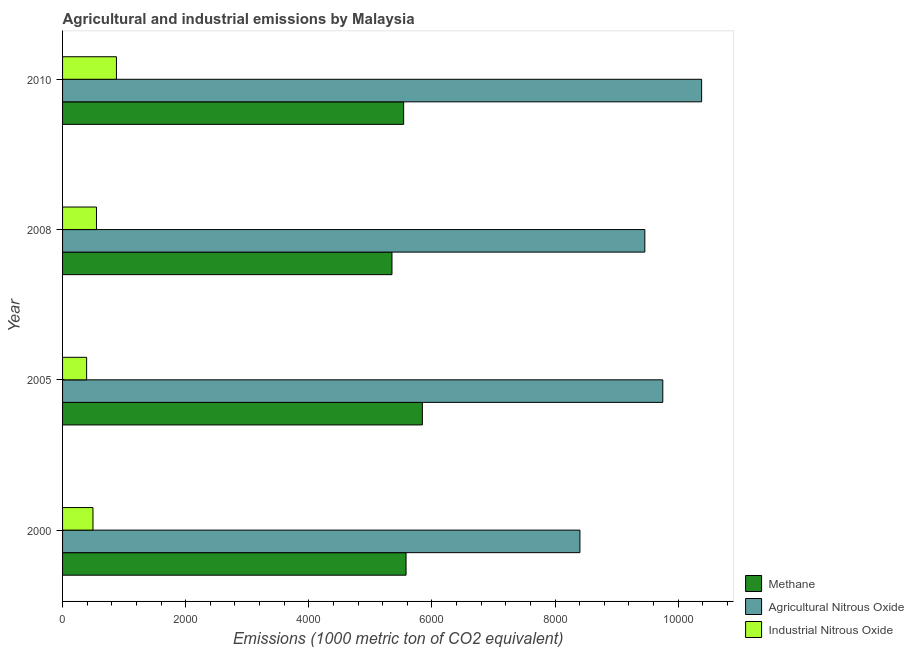How many groups of bars are there?
Provide a succinct answer. 4. Are the number of bars per tick equal to the number of legend labels?
Give a very brief answer. Yes. What is the label of the 3rd group of bars from the top?
Keep it short and to the point. 2005. In how many cases, is the number of bars for a given year not equal to the number of legend labels?
Provide a succinct answer. 0. What is the amount of industrial nitrous oxide emissions in 2010?
Ensure brevity in your answer.  874.9. Across all years, what is the maximum amount of methane emissions?
Provide a succinct answer. 5844. Across all years, what is the minimum amount of methane emissions?
Provide a short and direct response. 5350.3. In which year was the amount of agricultural nitrous oxide emissions maximum?
Make the answer very short. 2010. In which year was the amount of industrial nitrous oxide emissions minimum?
Offer a very short reply. 2005. What is the total amount of agricultural nitrous oxide emissions in the graph?
Give a very brief answer. 3.80e+04. What is the difference between the amount of methane emissions in 2000 and that in 2005?
Keep it short and to the point. -264.8. What is the difference between the amount of agricultural nitrous oxide emissions in 2000 and the amount of industrial nitrous oxide emissions in 2005?
Your answer should be compact. 8012.3. What is the average amount of methane emissions per year?
Give a very brief answer. 5578.45. In the year 2000, what is the difference between the amount of industrial nitrous oxide emissions and amount of methane emissions?
Provide a short and direct response. -5085.4. What is the ratio of the amount of methane emissions in 2000 to that in 2010?
Make the answer very short. 1.01. Is the amount of methane emissions in 2005 less than that in 2008?
Your answer should be very brief. No. What is the difference between the highest and the second highest amount of agricultural nitrous oxide emissions?
Give a very brief answer. 630.9. What is the difference between the highest and the lowest amount of agricultural nitrous oxide emissions?
Give a very brief answer. 1977. In how many years, is the amount of agricultural nitrous oxide emissions greater than the average amount of agricultural nitrous oxide emissions taken over all years?
Your answer should be very brief. 2. Is the sum of the amount of industrial nitrous oxide emissions in 2005 and 2010 greater than the maximum amount of methane emissions across all years?
Give a very brief answer. No. What does the 2nd bar from the top in 2010 represents?
Provide a succinct answer. Agricultural Nitrous Oxide. What does the 2nd bar from the bottom in 2010 represents?
Offer a very short reply. Agricultural Nitrous Oxide. Is it the case that in every year, the sum of the amount of methane emissions and amount of agricultural nitrous oxide emissions is greater than the amount of industrial nitrous oxide emissions?
Offer a very short reply. Yes. Are all the bars in the graph horizontal?
Provide a succinct answer. Yes. How many years are there in the graph?
Provide a short and direct response. 4. What is the difference between two consecutive major ticks on the X-axis?
Provide a succinct answer. 2000. Are the values on the major ticks of X-axis written in scientific E-notation?
Offer a terse response. No. Where does the legend appear in the graph?
Your answer should be very brief. Bottom right. What is the title of the graph?
Offer a very short reply. Agricultural and industrial emissions by Malaysia. What is the label or title of the X-axis?
Your answer should be compact. Emissions (1000 metric ton of CO2 equivalent). What is the Emissions (1000 metric ton of CO2 equivalent) of Methane in 2000?
Provide a short and direct response. 5579.2. What is the Emissions (1000 metric ton of CO2 equivalent) of Agricultural Nitrous Oxide in 2000?
Your answer should be compact. 8403.2. What is the Emissions (1000 metric ton of CO2 equivalent) in Industrial Nitrous Oxide in 2000?
Keep it short and to the point. 493.8. What is the Emissions (1000 metric ton of CO2 equivalent) in Methane in 2005?
Provide a succinct answer. 5844. What is the Emissions (1000 metric ton of CO2 equivalent) in Agricultural Nitrous Oxide in 2005?
Your answer should be very brief. 9749.3. What is the Emissions (1000 metric ton of CO2 equivalent) of Industrial Nitrous Oxide in 2005?
Your answer should be very brief. 390.9. What is the Emissions (1000 metric ton of CO2 equivalent) in Methane in 2008?
Ensure brevity in your answer.  5350.3. What is the Emissions (1000 metric ton of CO2 equivalent) in Agricultural Nitrous Oxide in 2008?
Provide a succinct answer. 9457.6. What is the Emissions (1000 metric ton of CO2 equivalent) of Industrial Nitrous Oxide in 2008?
Ensure brevity in your answer.  551. What is the Emissions (1000 metric ton of CO2 equivalent) of Methane in 2010?
Keep it short and to the point. 5540.3. What is the Emissions (1000 metric ton of CO2 equivalent) in Agricultural Nitrous Oxide in 2010?
Ensure brevity in your answer.  1.04e+04. What is the Emissions (1000 metric ton of CO2 equivalent) of Industrial Nitrous Oxide in 2010?
Your answer should be very brief. 874.9. Across all years, what is the maximum Emissions (1000 metric ton of CO2 equivalent) in Methane?
Give a very brief answer. 5844. Across all years, what is the maximum Emissions (1000 metric ton of CO2 equivalent) in Agricultural Nitrous Oxide?
Make the answer very short. 1.04e+04. Across all years, what is the maximum Emissions (1000 metric ton of CO2 equivalent) of Industrial Nitrous Oxide?
Offer a terse response. 874.9. Across all years, what is the minimum Emissions (1000 metric ton of CO2 equivalent) of Methane?
Provide a short and direct response. 5350.3. Across all years, what is the minimum Emissions (1000 metric ton of CO2 equivalent) in Agricultural Nitrous Oxide?
Provide a short and direct response. 8403.2. Across all years, what is the minimum Emissions (1000 metric ton of CO2 equivalent) in Industrial Nitrous Oxide?
Ensure brevity in your answer.  390.9. What is the total Emissions (1000 metric ton of CO2 equivalent) in Methane in the graph?
Ensure brevity in your answer.  2.23e+04. What is the total Emissions (1000 metric ton of CO2 equivalent) in Agricultural Nitrous Oxide in the graph?
Make the answer very short. 3.80e+04. What is the total Emissions (1000 metric ton of CO2 equivalent) of Industrial Nitrous Oxide in the graph?
Offer a terse response. 2310.6. What is the difference between the Emissions (1000 metric ton of CO2 equivalent) of Methane in 2000 and that in 2005?
Offer a very short reply. -264.8. What is the difference between the Emissions (1000 metric ton of CO2 equivalent) of Agricultural Nitrous Oxide in 2000 and that in 2005?
Offer a very short reply. -1346.1. What is the difference between the Emissions (1000 metric ton of CO2 equivalent) of Industrial Nitrous Oxide in 2000 and that in 2005?
Offer a terse response. 102.9. What is the difference between the Emissions (1000 metric ton of CO2 equivalent) of Methane in 2000 and that in 2008?
Provide a short and direct response. 228.9. What is the difference between the Emissions (1000 metric ton of CO2 equivalent) in Agricultural Nitrous Oxide in 2000 and that in 2008?
Your answer should be very brief. -1054.4. What is the difference between the Emissions (1000 metric ton of CO2 equivalent) of Industrial Nitrous Oxide in 2000 and that in 2008?
Give a very brief answer. -57.2. What is the difference between the Emissions (1000 metric ton of CO2 equivalent) of Methane in 2000 and that in 2010?
Give a very brief answer. 38.9. What is the difference between the Emissions (1000 metric ton of CO2 equivalent) of Agricultural Nitrous Oxide in 2000 and that in 2010?
Provide a succinct answer. -1977. What is the difference between the Emissions (1000 metric ton of CO2 equivalent) in Industrial Nitrous Oxide in 2000 and that in 2010?
Your answer should be very brief. -381.1. What is the difference between the Emissions (1000 metric ton of CO2 equivalent) in Methane in 2005 and that in 2008?
Give a very brief answer. 493.7. What is the difference between the Emissions (1000 metric ton of CO2 equivalent) of Agricultural Nitrous Oxide in 2005 and that in 2008?
Provide a short and direct response. 291.7. What is the difference between the Emissions (1000 metric ton of CO2 equivalent) of Industrial Nitrous Oxide in 2005 and that in 2008?
Offer a very short reply. -160.1. What is the difference between the Emissions (1000 metric ton of CO2 equivalent) in Methane in 2005 and that in 2010?
Your answer should be compact. 303.7. What is the difference between the Emissions (1000 metric ton of CO2 equivalent) of Agricultural Nitrous Oxide in 2005 and that in 2010?
Your answer should be very brief. -630.9. What is the difference between the Emissions (1000 metric ton of CO2 equivalent) in Industrial Nitrous Oxide in 2005 and that in 2010?
Provide a succinct answer. -484. What is the difference between the Emissions (1000 metric ton of CO2 equivalent) of Methane in 2008 and that in 2010?
Keep it short and to the point. -190. What is the difference between the Emissions (1000 metric ton of CO2 equivalent) of Agricultural Nitrous Oxide in 2008 and that in 2010?
Your response must be concise. -922.6. What is the difference between the Emissions (1000 metric ton of CO2 equivalent) of Industrial Nitrous Oxide in 2008 and that in 2010?
Keep it short and to the point. -323.9. What is the difference between the Emissions (1000 metric ton of CO2 equivalent) in Methane in 2000 and the Emissions (1000 metric ton of CO2 equivalent) in Agricultural Nitrous Oxide in 2005?
Offer a terse response. -4170.1. What is the difference between the Emissions (1000 metric ton of CO2 equivalent) of Methane in 2000 and the Emissions (1000 metric ton of CO2 equivalent) of Industrial Nitrous Oxide in 2005?
Your answer should be very brief. 5188.3. What is the difference between the Emissions (1000 metric ton of CO2 equivalent) of Agricultural Nitrous Oxide in 2000 and the Emissions (1000 metric ton of CO2 equivalent) of Industrial Nitrous Oxide in 2005?
Keep it short and to the point. 8012.3. What is the difference between the Emissions (1000 metric ton of CO2 equivalent) of Methane in 2000 and the Emissions (1000 metric ton of CO2 equivalent) of Agricultural Nitrous Oxide in 2008?
Make the answer very short. -3878.4. What is the difference between the Emissions (1000 metric ton of CO2 equivalent) of Methane in 2000 and the Emissions (1000 metric ton of CO2 equivalent) of Industrial Nitrous Oxide in 2008?
Ensure brevity in your answer.  5028.2. What is the difference between the Emissions (1000 metric ton of CO2 equivalent) of Agricultural Nitrous Oxide in 2000 and the Emissions (1000 metric ton of CO2 equivalent) of Industrial Nitrous Oxide in 2008?
Your response must be concise. 7852.2. What is the difference between the Emissions (1000 metric ton of CO2 equivalent) of Methane in 2000 and the Emissions (1000 metric ton of CO2 equivalent) of Agricultural Nitrous Oxide in 2010?
Keep it short and to the point. -4801. What is the difference between the Emissions (1000 metric ton of CO2 equivalent) in Methane in 2000 and the Emissions (1000 metric ton of CO2 equivalent) in Industrial Nitrous Oxide in 2010?
Your answer should be compact. 4704.3. What is the difference between the Emissions (1000 metric ton of CO2 equivalent) in Agricultural Nitrous Oxide in 2000 and the Emissions (1000 metric ton of CO2 equivalent) in Industrial Nitrous Oxide in 2010?
Keep it short and to the point. 7528.3. What is the difference between the Emissions (1000 metric ton of CO2 equivalent) of Methane in 2005 and the Emissions (1000 metric ton of CO2 equivalent) of Agricultural Nitrous Oxide in 2008?
Offer a terse response. -3613.6. What is the difference between the Emissions (1000 metric ton of CO2 equivalent) in Methane in 2005 and the Emissions (1000 metric ton of CO2 equivalent) in Industrial Nitrous Oxide in 2008?
Your answer should be very brief. 5293. What is the difference between the Emissions (1000 metric ton of CO2 equivalent) in Agricultural Nitrous Oxide in 2005 and the Emissions (1000 metric ton of CO2 equivalent) in Industrial Nitrous Oxide in 2008?
Provide a succinct answer. 9198.3. What is the difference between the Emissions (1000 metric ton of CO2 equivalent) in Methane in 2005 and the Emissions (1000 metric ton of CO2 equivalent) in Agricultural Nitrous Oxide in 2010?
Your response must be concise. -4536.2. What is the difference between the Emissions (1000 metric ton of CO2 equivalent) in Methane in 2005 and the Emissions (1000 metric ton of CO2 equivalent) in Industrial Nitrous Oxide in 2010?
Ensure brevity in your answer.  4969.1. What is the difference between the Emissions (1000 metric ton of CO2 equivalent) in Agricultural Nitrous Oxide in 2005 and the Emissions (1000 metric ton of CO2 equivalent) in Industrial Nitrous Oxide in 2010?
Provide a short and direct response. 8874.4. What is the difference between the Emissions (1000 metric ton of CO2 equivalent) in Methane in 2008 and the Emissions (1000 metric ton of CO2 equivalent) in Agricultural Nitrous Oxide in 2010?
Keep it short and to the point. -5029.9. What is the difference between the Emissions (1000 metric ton of CO2 equivalent) in Methane in 2008 and the Emissions (1000 metric ton of CO2 equivalent) in Industrial Nitrous Oxide in 2010?
Offer a terse response. 4475.4. What is the difference between the Emissions (1000 metric ton of CO2 equivalent) of Agricultural Nitrous Oxide in 2008 and the Emissions (1000 metric ton of CO2 equivalent) of Industrial Nitrous Oxide in 2010?
Keep it short and to the point. 8582.7. What is the average Emissions (1000 metric ton of CO2 equivalent) in Methane per year?
Your answer should be compact. 5578.45. What is the average Emissions (1000 metric ton of CO2 equivalent) in Agricultural Nitrous Oxide per year?
Make the answer very short. 9497.58. What is the average Emissions (1000 metric ton of CO2 equivalent) of Industrial Nitrous Oxide per year?
Your answer should be very brief. 577.65. In the year 2000, what is the difference between the Emissions (1000 metric ton of CO2 equivalent) of Methane and Emissions (1000 metric ton of CO2 equivalent) of Agricultural Nitrous Oxide?
Provide a short and direct response. -2824. In the year 2000, what is the difference between the Emissions (1000 metric ton of CO2 equivalent) in Methane and Emissions (1000 metric ton of CO2 equivalent) in Industrial Nitrous Oxide?
Your answer should be very brief. 5085.4. In the year 2000, what is the difference between the Emissions (1000 metric ton of CO2 equivalent) in Agricultural Nitrous Oxide and Emissions (1000 metric ton of CO2 equivalent) in Industrial Nitrous Oxide?
Ensure brevity in your answer.  7909.4. In the year 2005, what is the difference between the Emissions (1000 metric ton of CO2 equivalent) in Methane and Emissions (1000 metric ton of CO2 equivalent) in Agricultural Nitrous Oxide?
Provide a succinct answer. -3905.3. In the year 2005, what is the difference between the Emissions (1000 metric ton of CO2 equivalent) in Methane and Emissions (1000 metric ton of CO2 equivalent) in Industrial Nitrous Oxide?
Your answer should be very brief. 5453.1. In the year 2005, what is the difference between the Emissions (1000 metric ton of CO2 equivalent) in Agricultural Nitrous Oxide and Emissions (1000 metric ton of CO2 equivalent) in Industrial Nitrous Oxide?
Ensure brevity in your answer.  9358.4. In the year 2008, what is the difference between the Emissions (1000 metric ton of CO2 equivalent) in Methane and Emissions (1000 metric ton of CO2 equivalent) in Agricultural Nitrous Oxide?
Your response must be concise. -4107.3. In the year 2008, what is the difference between the Emissions (1000 metric ton of CO2 equivalent) of Methane and Emissions (1000 metric ton of CO2 equivalent) of Industrial Nitrous Oxide?
Your answer should be very brief. 4799.3. In the year 2008, what is the difference between the Emissions (1000 metric ton of CO2 equivalent) in Agricultural Nitrous Oxide and Emissions (1000 metric ton of CO2 equivalent) in Industrial Nitrous Oxide?
Ensure brevity in your answer.  8906.6. In the year 2010, what is the difference between the Emissions (1000 metric ton of CO2 equivalent) of Methane and Emissions (1000 metric ton of CO2 equivalent) of Agricultural Nitrous Oxide?
Offer a very short reply. -4839.9. In the year 2010, what is the difference between the Emissions (1000 metric ton of CO2 equivalent) in Methane and Emissions (1000 metric ton of CO2 equivalent) in Industrial Nitrous Oxide?
Your response must be concise. 4665.4. In the year 2010, what is the difference between the Emissions (1000 metric ton of CO2 equivalent) of Agricultural Nitrous Oxide and Emissions (1000 metric ton of CO2 equivalent) of Industrial Nitrous Oxide?
Provide a succinct answer. 9505.3. What is the ratio of the Emissions (1000 metric ton of CO2 equivalent) of Methane in 2000 to that in 2005?
Give a very brief answer. 0.95. What is the ratio of the Emissions (1000 metric ton of CO2 equivalent) in Agricultural Nitrous Oxide in 2000 to that in 2005?
Provide a succinct answer. 0.86. What is the ratio of the Emissions (1000 metric ton of CO2 equivalent) in Industrial Nitrous Oxide in 2000 to that in 2005?
Make the answer very short. 1.26. What is the ratio of the Emissions (1000 metric ton of CO2 equivalent) in Methane in 2000 to that in 2008?
Provide a short and direct response. 1.04. What is the ratio of the Emissions (1000 metric ton of CO2 equivalent) of Agricultural Nitrous Oxide in 2000 to that in 2008?
Your response must be concise. 0.89. What is the ratio of the Emissions (1000 metric ton of CO2 equivalent) of Industrial Nitrous Oxide in 2000 to that in 2008?
Make the answer very short. 0.9. What is the ratio of the Emissions (1000 metric ton of CO2 equivalent) in Agricultural Nitrous Oxide in 2000 to that in 2010?
Ensure brevity in your answer.  0.81. What is the ratio of the Emissions (1000 metric ton of CO2 equivalent) in Industrial Nitrous Oxide in 2000 to that in 2010?
Offer a very short reply. 0.56. What is the ratio of the Emissions (1000 metric ton of CO2 equivalent) of Methane in 2005 to that in 2008?
Ensure brevity in your answer.  1.09. What is the ratio of the Emissions (1000 metric ton of CO2 equivalent) in Agricultural Nitrous Oxide in 2005 to that in 2008?
Provide a short and direct response. 1.03. What is the ratio of the Emissions (1000 metric ton of CO2 equivalent) of Industrial Nitrous Oxide in 2005 to that in 2008?
Your answer should be very brief. 0.71. What is the ratio of the Emissions (1000 metric ton of CO2 equivalent) of Methane in 2005 to that in 2010?
Provide a succinct answer. 1.05. What is the ratio of the Emissions (1000 metric ton of CO2 equivalent) in Agricultural Nitrous Oxide in 2005 to that in 2010?
Offer a very short reply. 0.94. What is the ratio of the Emissions (1000 metric ton of CO2 equivalent) in Industrial Nitrous Oxide in 2005 to that in 2010?
Offer a very short reply. 0.45. What is the ratio of the Emissions (1000 metric ton of CO2 equivalent) of Methane in 2008 to that in 2010?
Provide a short and direct response. 0.97. What is the ratio of the Emissions (1000 metric ton of CO2 equivalent) in Agricultural Nitrous Oxide in 2008 to that in 2010?
Keep it short and to the point. 0.91. What is the ratio of the Emissions (1000 metric ton of CO2 equivalent) in Industrial Nitrous Oxide in 2008 to that in 2010?
Your response must be concise. 0.63. What is the difference between the highest and the second highest Emissions (1000 metric ton of CO2 equivalent) of Methane?
Offer a very short reply. 264.8. What is the difference between the highest and the second highest Emissions (1000 metric ton of CO2 equivalent) of Agricultural Nitrous Oxide?
Your response must be concise. 630.9. What is the difference between the highest and the second highest Emissions (1000 metric ton of CO2 equivalent) in Industrial Nitrous Oxide?
Make the answer very short. 323.9. What is the difference between the highest and the lowest Emissions (1000 metric ton of CO2 equivalent) in Methane?
Your answer should be compact. 493.7. What is the difference between the highest and the lowest Emissions (1000 metric ton of CO2 equivalent) of Agricultural Nitrous Oxide?
Keep it short and to the point. 1977. What is the difference between the highest and the lowest Emissions (1000 metric ton of CO2 equivalent) of Industrial Nitrous Oxide?
Provide a succinct answer. 484. 